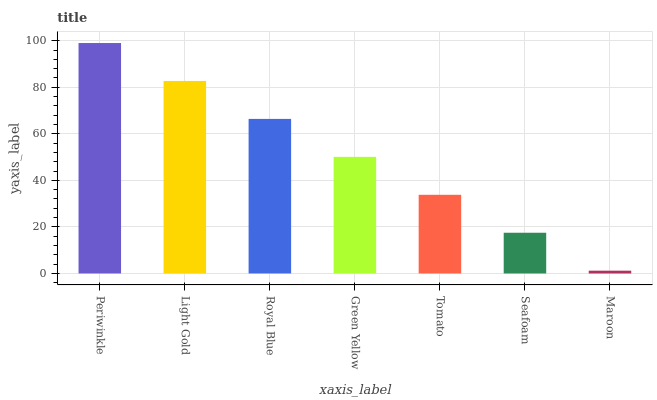Is Maroon the minimum?
Answer yes or no. Yes. Is Periwinkle the maximum?
Answer yes or no. Yes. Is Light Gold the minimum?
Answer yes or no. No. Is Light Gold the maximum?
Answer yes or no. No. Is Periwinkle greater than Light Gold?
Answer yes or no. Yes. Is Light Gold less than Periwinkle?
Answer yes or no. Yes. Is Light Gold greater than Periwinkle?
Answer yes or no. No. Is Periwinkle less than Light Gold?
Answer yes or no. No. Is Green Yellow the high median?
Answer yes or no. Yes. Is Green Yellow the low median?
Answer yes or no. Yes. Is Seafoam the high median?
Answer yes or no. No. Is Light Gold the low median?
Answer yes or no. No. 